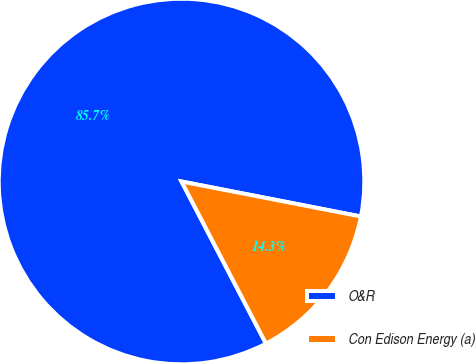Convert chart. <chart><loc_0><loc_0><loc_500><loc_500><pie_chart><fcel>O&R<fcel>Con Edison Energy (a)<nl><fcel>85.71%<fcel>14.29%<nl></chart> 